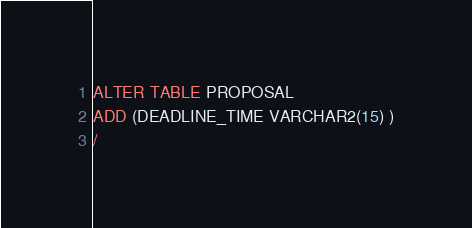Convert code to text. <code><loc_0><loc_0><loc_500><loc_500><_SQL_>ALTER TABLE PROPOSAL 
ADD (DEADLINE_TIME VARCHAR2(15) )
/
</code> 